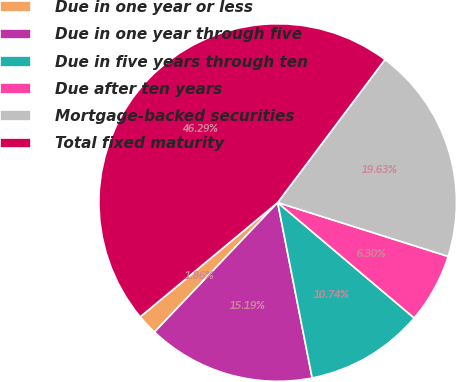<chart> <loc_0><loc_0><loc_500><loc_500><pie_chart><fcel>Due in one year or less<fcel>Due in one year through five<fcel>Due in five years through ten<fcel>Due after ten years<fcel>Mortgage-backed securities<fcel>Total fixed maturity<nl><fcel>1.86%<fcel>15.19%<fcel>10.74%<fcel>6.3%<fcel>19.63%<fcel>46.29%<nl></chart> 